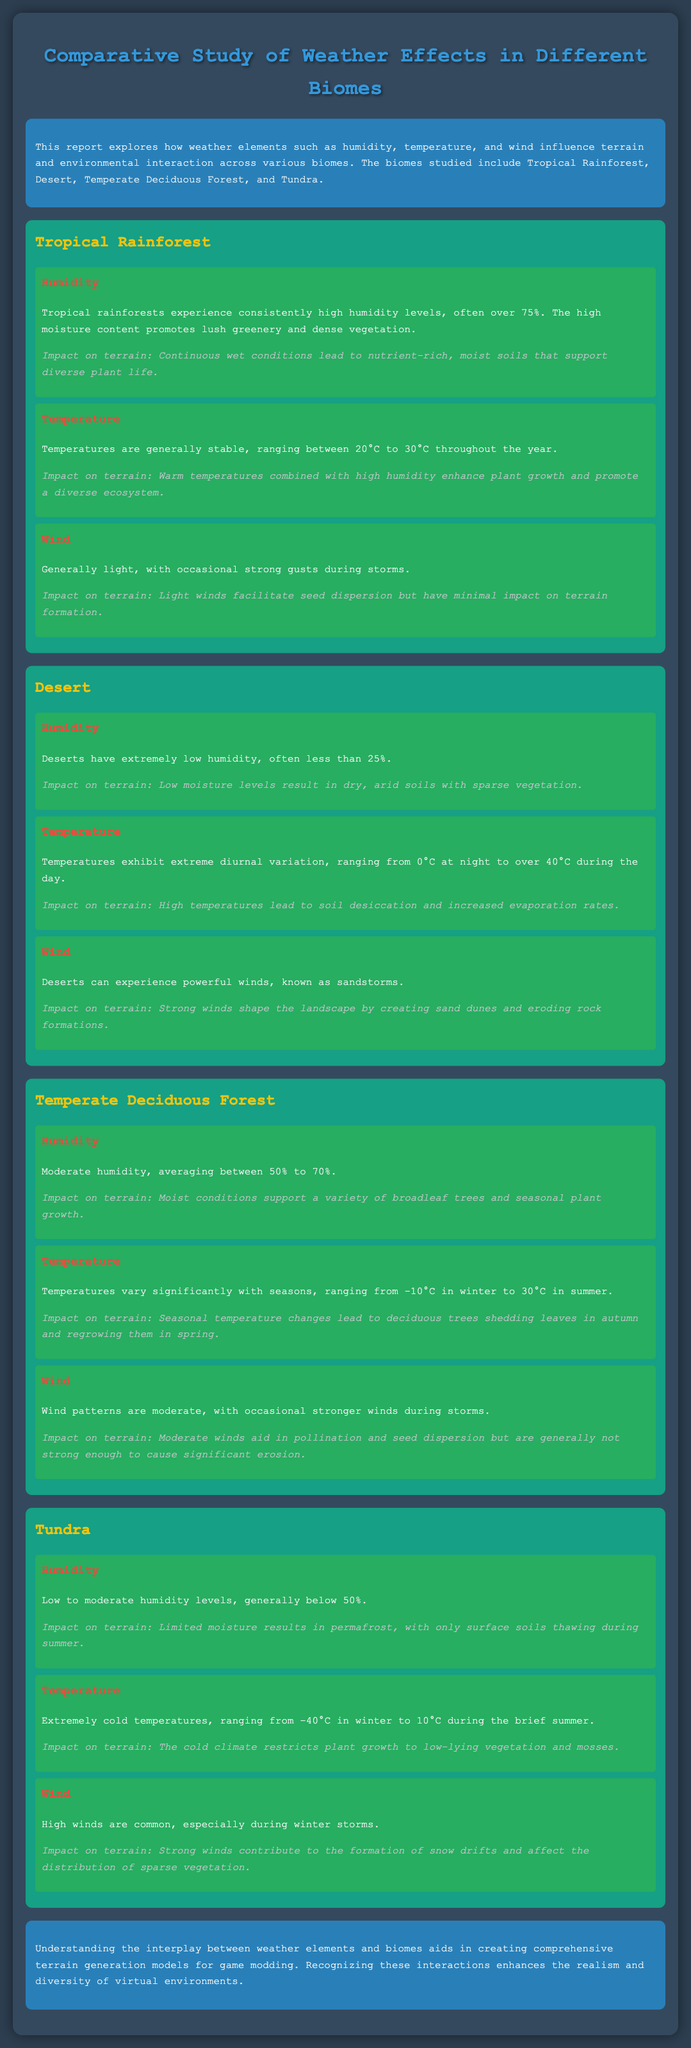what is the humidity level in Tropical Rainforest? The Tropical Rainforest experiences consistently high humidity levels, often over 75%.
Answer: over 75% what is the temperature range in Tundra? The Tundra has extremely cold temperatures, ranging from -40°C in winter to 10°C during the brief summer.
Answer: -40°C to 10°C which biome experiences the highest temperature variation? Deserts exhibit extreme diurnal variation, with temperatures ranging from 0°C at night to over 40°C during the day.
Answer: Desert what is the impact of high humidity on Tropical Rainforest terrain? Continuous wet conditions lead to nutrient-rich, moist soils that support diverse plant life.
Answer: nutrient-rich, moist soils how do strong winds affect Tundra vegetation? Strong winds contribute to the formation of snow drifts and affect the distribution of sparse vegetation.
Answer: affect the distribution of sparse vegetation which biome has the highest average humidity? Tropical Rainforest has consistently high humidity levels, often over 75%.
Answer: Tropical Rainforest what factor promotes lush greenery in Tropical Rainforest? The high moisture content promotes lush greenery and dense vegetation.
Answer: high moisture content what is the primary factor for soil desiccation in Desert? High temperatures lead to soil desiccation and increased evaporation rates.
Answer: High temperatures what type of vegetation is primarily found in Tundra? The cold climate restricts plant growth to low-lying vegetation and mosses.
Answer: low-lying vegetation and mosses 